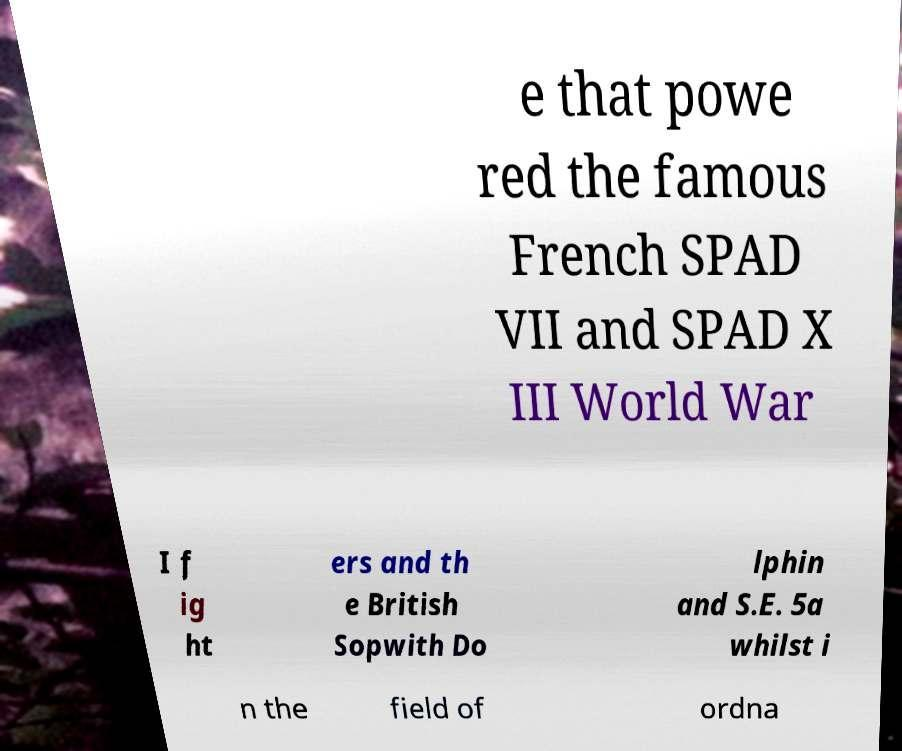Please read and relay the text visible in this image. What does it say? e that powe red the famous French SPAD VII and SPAD X III World War I f ig ht ers and th e British Sopwith Do lphin and S.E. 5a whilst i n the field of ordna 